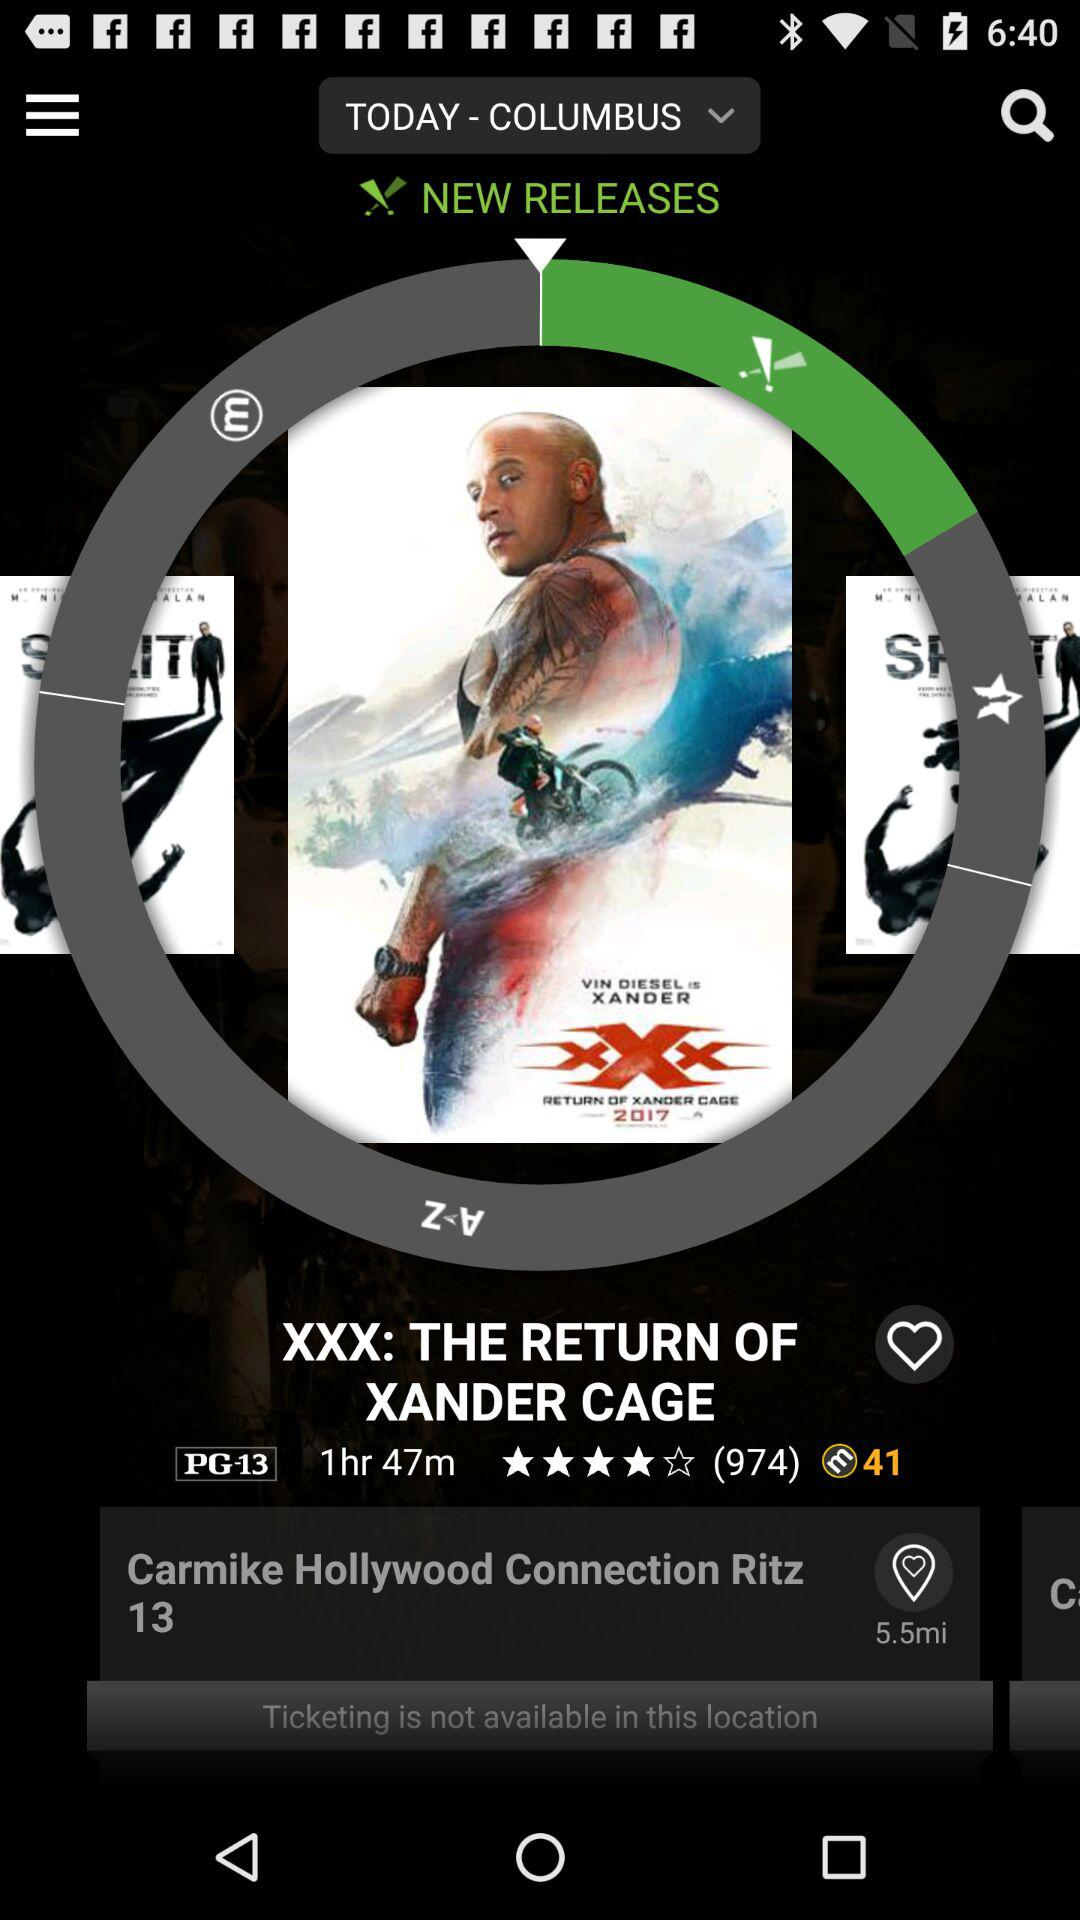What is the name of the new release? The name of the new release is XXX: THE RETURN OF XANDER CAGE. 